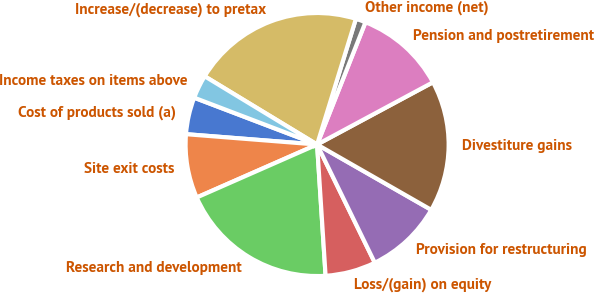Convert chart. <chart><loc_0><loc_0><loc_500><loc_500><pie_chart><fcel>Cost of products sold (a)<fcel>Site exit costs<fcel>Research and development<fcel>Loss/(gain) on equity<fcel>Provision for restructuring<fcel>Divestiture gains<fcel>Pension and postretirement<fcel>Other income (net)<fcel>Increase/(decrease) to pretax<fcel>Income taxes on items above<nl><fcel>4.54%<fcel>7.85%<fcel>19.43%<fcel>6.2%<fcel>9.5%<fcel>16.12%<fcel>11.16%<fcel>1.23%<fcel>21.08%<fcel>2.89%<nl></chart> 